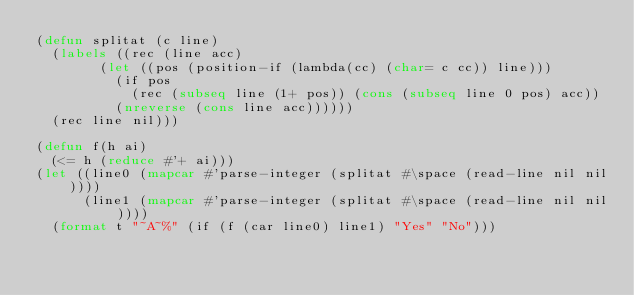<code> <loc_0><loc_0><loc_500><loc_500><_Lisp_>(defun splitat (c line)
  (labels ((rec (line acc)
				(let ((pos (position-if (lambda(cc) (char= c cc)) line)))
				  (if pos
					  (rec (subseq line (1+ pos)) (cons (subseq line 0 pos) acc))
					(nreverse (cons line acc))))))
	(rec line nil)))

(defun f(h ai)
  (<= h (reduce #'+ ai)))
(let ((line0 (mapcar #'parse-integer (splitat #\space (read-line nil nil))))
      (line1 (mapcar #'parse-integer (splitat #\space (read-line nil nil))))
  (format t "~A~%" (if (f (car line0) line1) "Yes" "No")))
</code> 